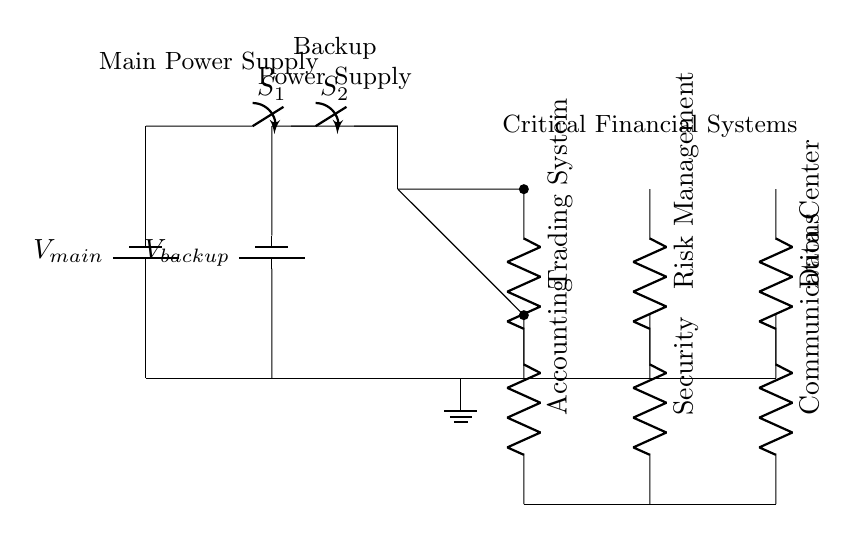What are the two power sources in this circuit? The circuit has a main power source labeled as "V_main" and a backup power source labeled "V_backup."
Answer: V_main, V_backup How many critical systems are connected to this circuit? There are six critical systems connected, which include Trading System, Risk Management, Data Center, Accounting, Security, and Communications.
Answer: Six What happens to the systems when both switches are closed? When both switches S1 and S2 are closed, both the main and backup power sources can supply power to all the connected critical systems simultaneously, ensuring power availability.
Answer: Systems are powered Which component ensures that one of the power sources is available? The switches (S1 and S2) act as a mechanism to choose between the main and backup power sources depending on their status (open or closed).
Answer: Switches How do you identify the distribution method of this circuit? This circuit is designed in parallel since it has multiple branches that allow each critical system to receive power independently from both sources.
Answer: Parallel What is the role of the backup power source in this circuit? The backup power source provides alternative power to critical systems in case the main power source fails, ensuring uninterrupted operation.
Answer: Alternative power What would happen if the main power supply fails and switch S1 is open? If S1 is open, the backup power supply cannot power the systems, leading to a loss of power to all connected systems.
Answer: Systems lose power 